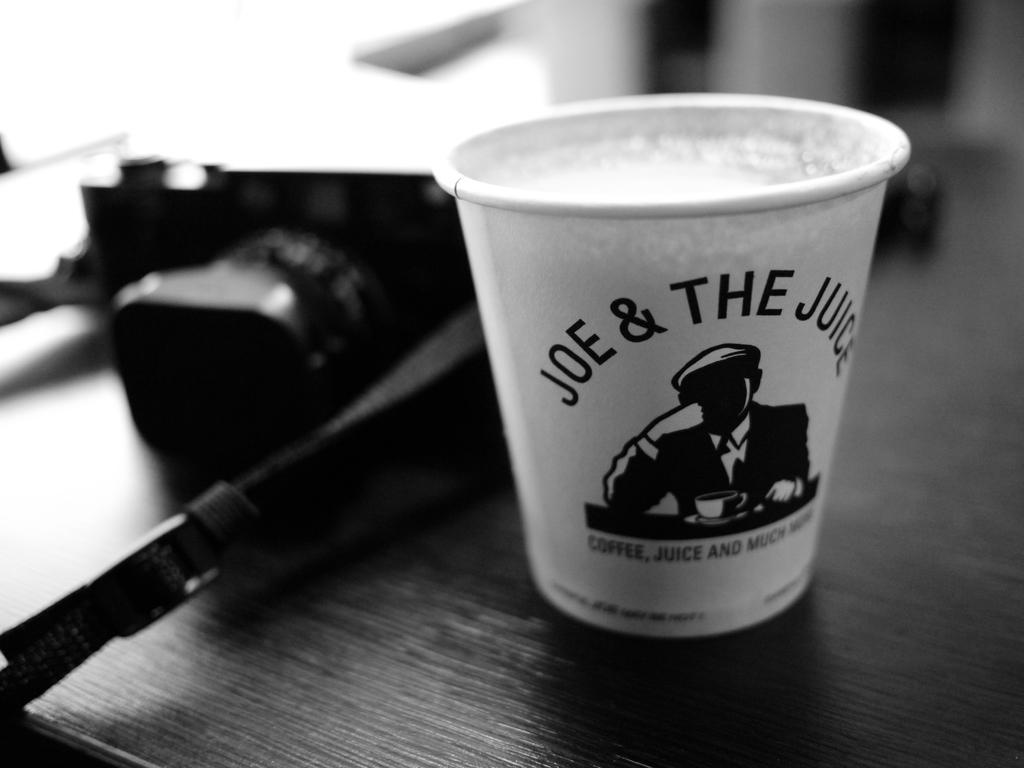<image>
Present a compact description of the photo's key features. a coffee from joe and the juice is shown 